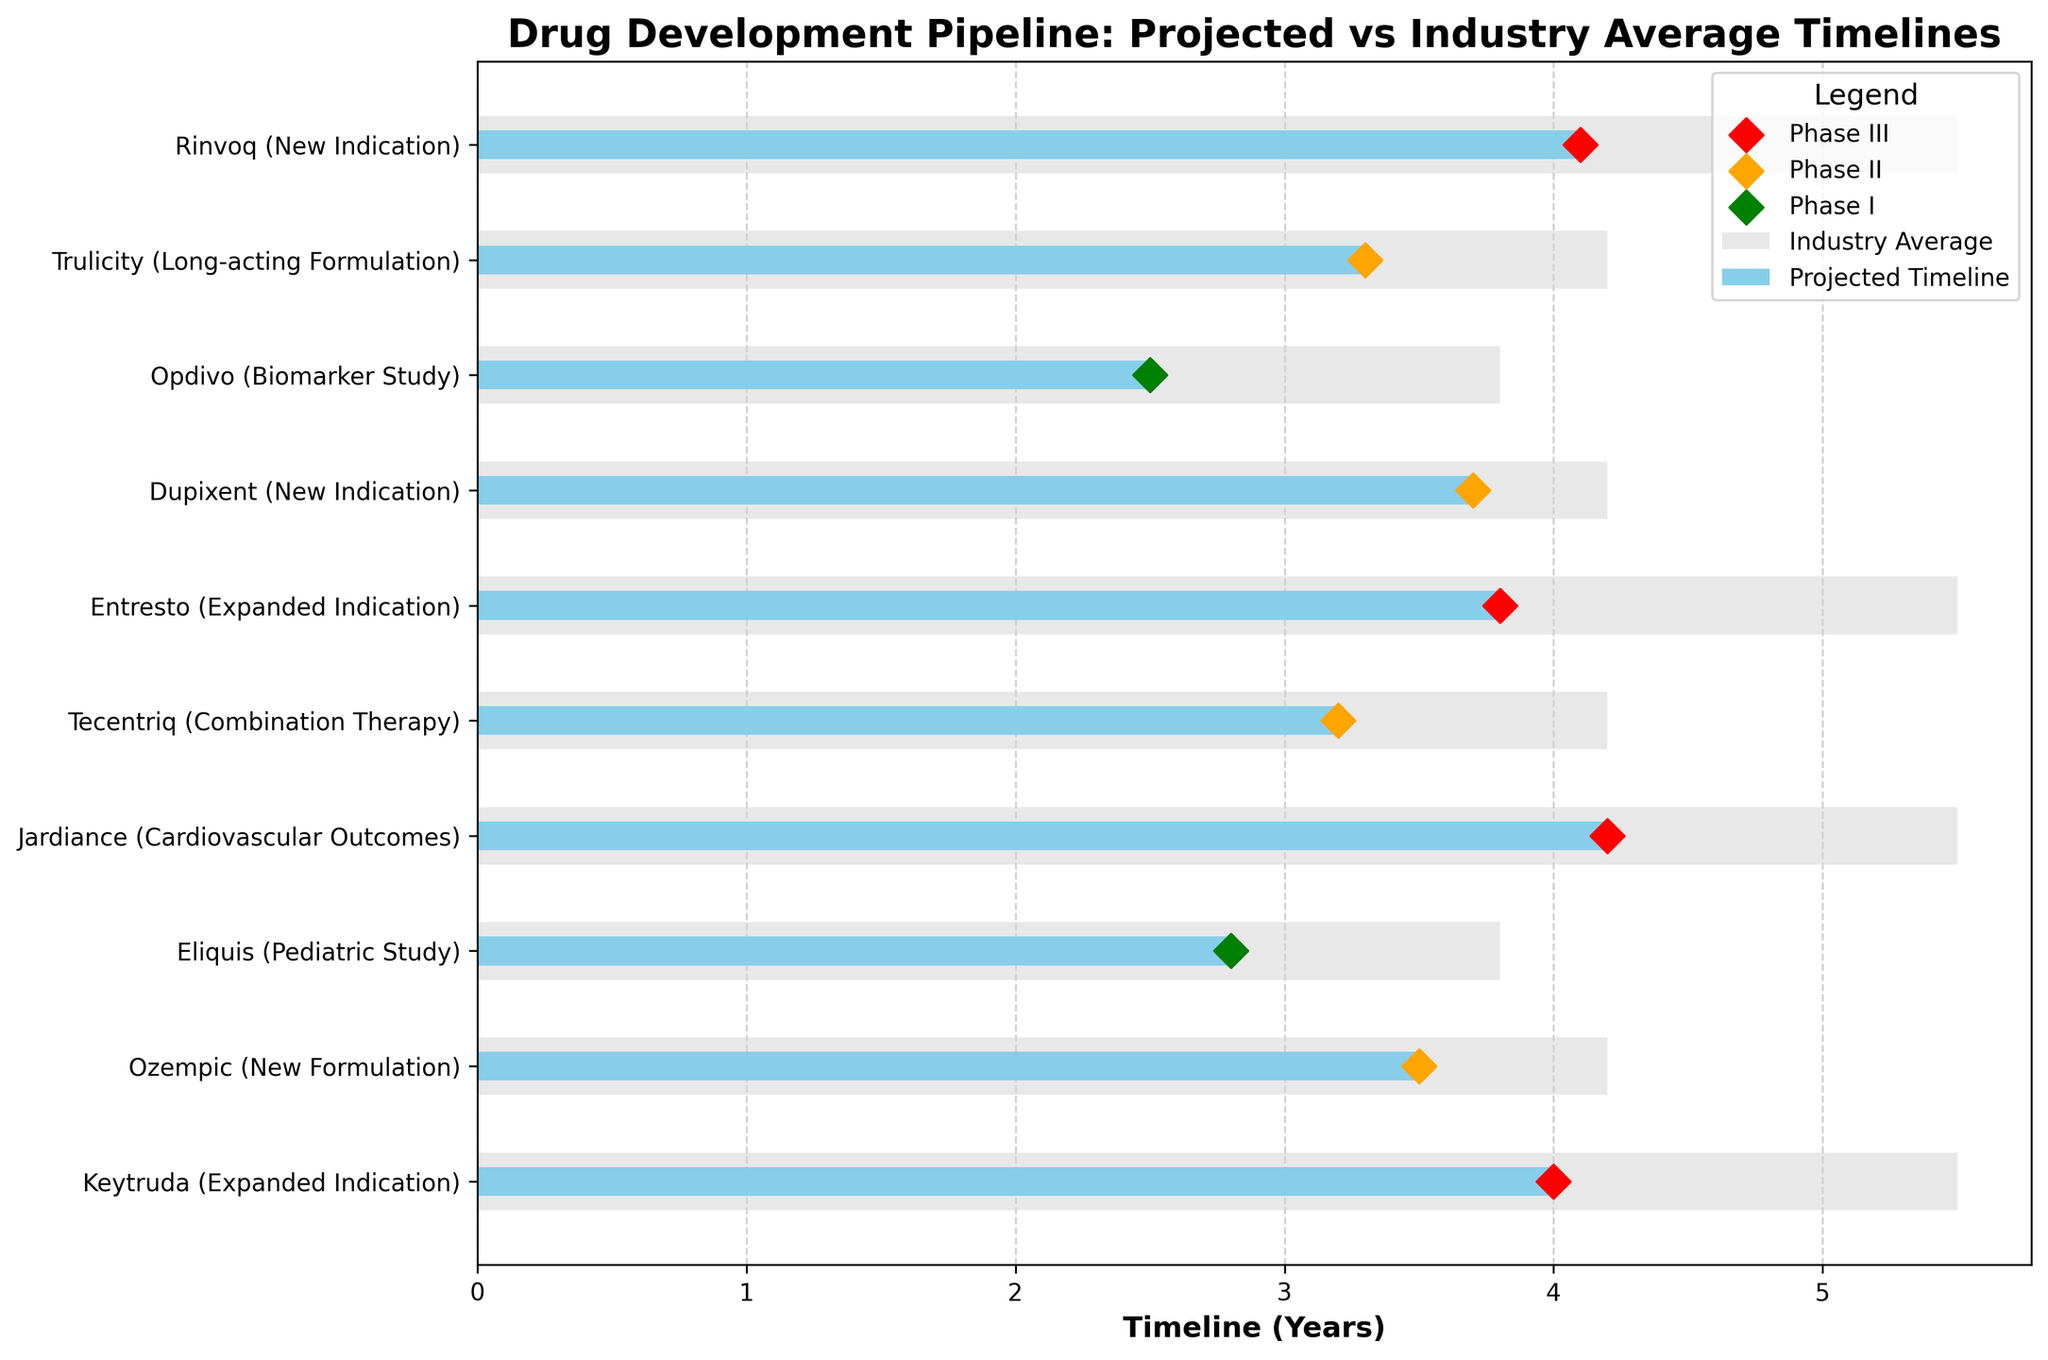What's the title of the plot? The title of the plot is located at the top center and is "Drug Development Pipeline: Projected vs Industry Average Timelines".
Answer: Drug Development Pipeline: Projected vs Industry Average Timelines How many drugs are displayed in the plot? The number of drugs displayed in the plot can be determined by counting the drugs listed on the y-axis. There are 10 drugs in total.
Answer: 10 What color represents the Phase III markers? The Phase III markers are represented by red diamond shapes in the plot.
Answer: Red Which drug has the shortest projected timeline? To find the drug with the shortest projected timeline, look for the shortest blue bar on the horizontal axis. The shortest blue bar corresponds to Opdivo with a timeline of 2.5 years.
Answer: Opdivo Which stage has the highest number of drugs in this pipeline? Count the occurrences of each stage: Phase I appears 2 times, Phase II appears 4 times, and Phase III appears 4 times. Both Phase II and Phase III have the highest number of drugs in this pipeline.
Answer: Phase II and Phase III What is the projected timeline for Tecentriq, and how does it compare to the industry average? The projected timeline for Tecentriq is 3.2 years, as indicated by the length of the blue bar. The industry average for drugs in Phase II, like Tecentriq, is 4.2 years. Therefore, Tecentriq's timeline is 1 year shorter than the industry average.
Answer: 3.2 years, 1 year shorter Which drug has the greatest difference between its projected timeline and the industry average? Calculate the differences between the projected timelines and industry averages for each drug. Keytruda (Expanded Indication) has a projected timeline of 4 years and an industry average of 5.5 years, resulting in a difference of 1.5 years, which is the largest difference observed.
Answer: Keytruda (Expanded Indication) How many drugs in Phase II have projected timelines shorter than the industry average? By examining the orange markers and comparing the blue bar lengths for the Phase II drugs: Ozempic, Tecentriq, Dupixent, and Trulicity, all of them have shorter projected timelines than the industry average (4.2 years).
Answer: 4 What is the range of projected timelines for the drugs in Phase III? Find the minimum and maximum projected timelines for drugs in Phase III: Keytruda (4 years), Jardiance (4.2 years), Entresto (3.8 years), and Rinvoq (4.1 years). The range is from 3.8 years to 4.2 years.
Answer: 3.8 to 4.2 years How does the projected timeline for Entresto compare relative to both the industry average and the other drugs in Phase III? The projected timeline for Entresto is 3.8 years. For drugs in Phase III, the industry average is 5.5 years, thus Entresto's timeline is 1.7 years shorter. Compared to the other Phase III drugs, Entresto has the shortest projected timeline.
Answer: 3.8 years, 1.7 years shorter than the industry average, shortest among Phase III 